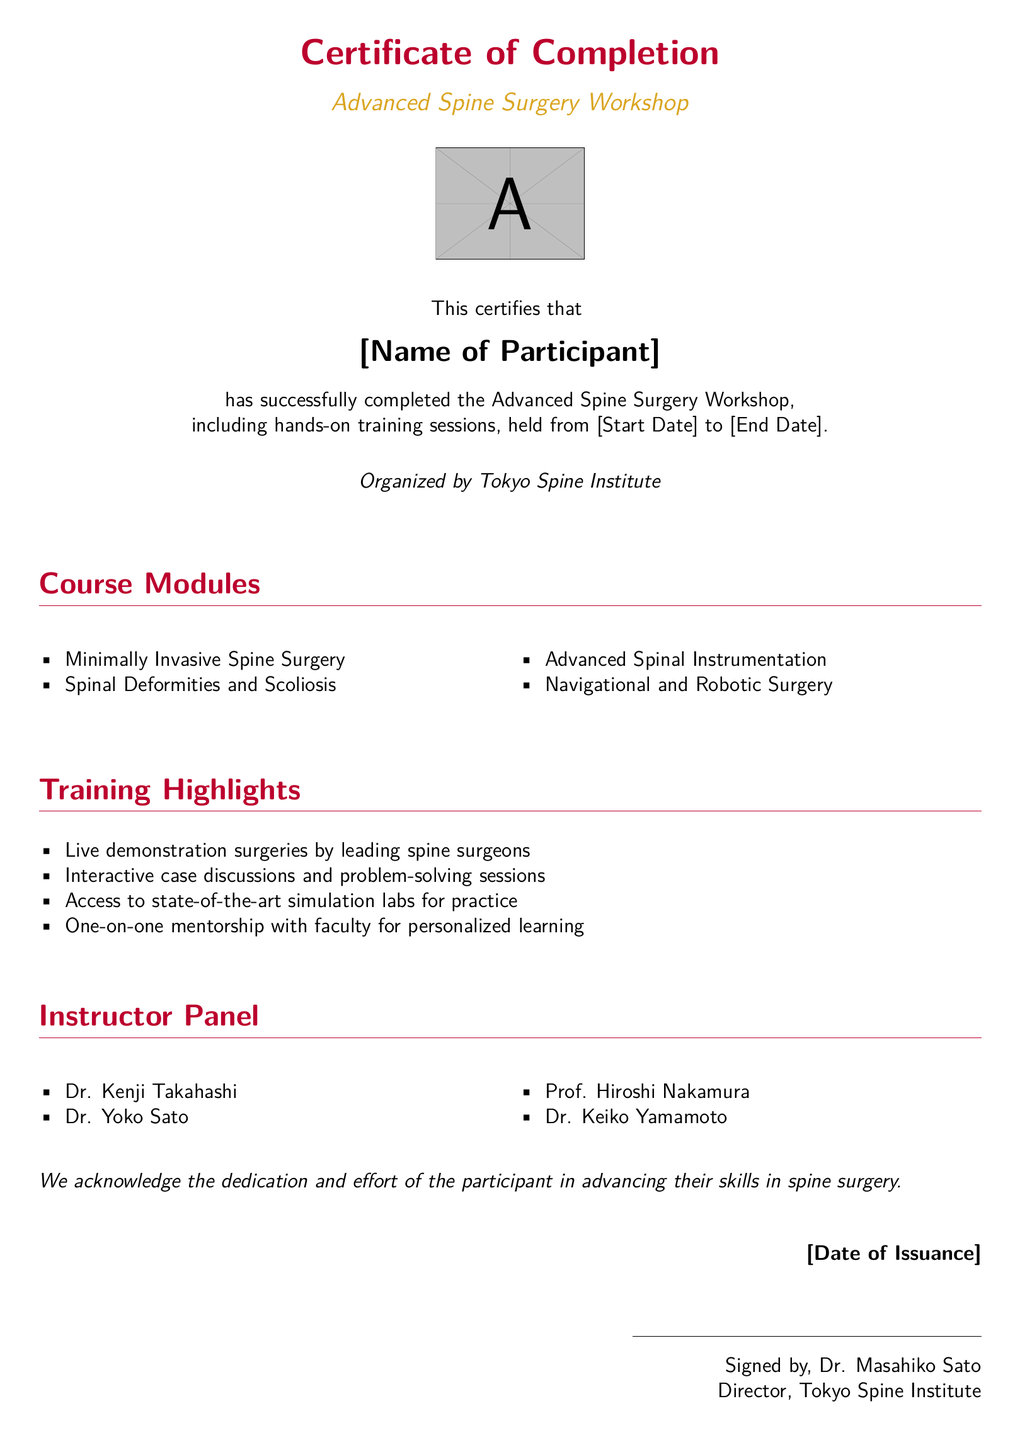What is the title of the workshop? The title of the workshop is clearly stated in the document.
Answer: Advanced Spine Surgery Workshop Who organized the workshop? The organization responsible for the workshop is mentioned prominently in the document.
Answer: Tokyo Spine Institute What are the dates of the workshop? The document specifies the start and end dates for the workshop, which are placeholders.
Answer: [Start Date] to [End Date] Who signed the certificate? The signature at the bottom of the document identifies the person who signed the certificate.
Answer: Dr. Masahiko Sato What is one of the course modules? The document includes a list of course modules that participants learned about.
Answer: Minimally Invasive Spine Surgery What type of training did participants receive? The document emphasizes the nature of the training sessions held during the workshop.
Answer: hands-on training sessions How many instructors are listed? The number of instructors is provided in the instructor panel section of the document.
Answer: Four What was a highlight of the training? The document lists several highlights that occurred during the training sessions.
Answer: Live demonstration surgeries What is the document type? The overall nature of the document is described at the very top.
Answer: Certificate of Completion 